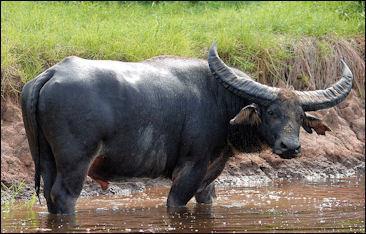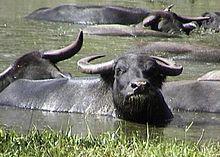The first image is the image on the left, the second image is the image on the right. For the images displayed, is the sentence "Left image shows one forward-facing water buffalo standing on dry ground." factually correct? Answer yes or no. No. The first image is the image on the left, the second image is the image on the right. Assess this claim about the two images: "None of the animals are near the water.". Correct or not? Answer yes or no. No. 